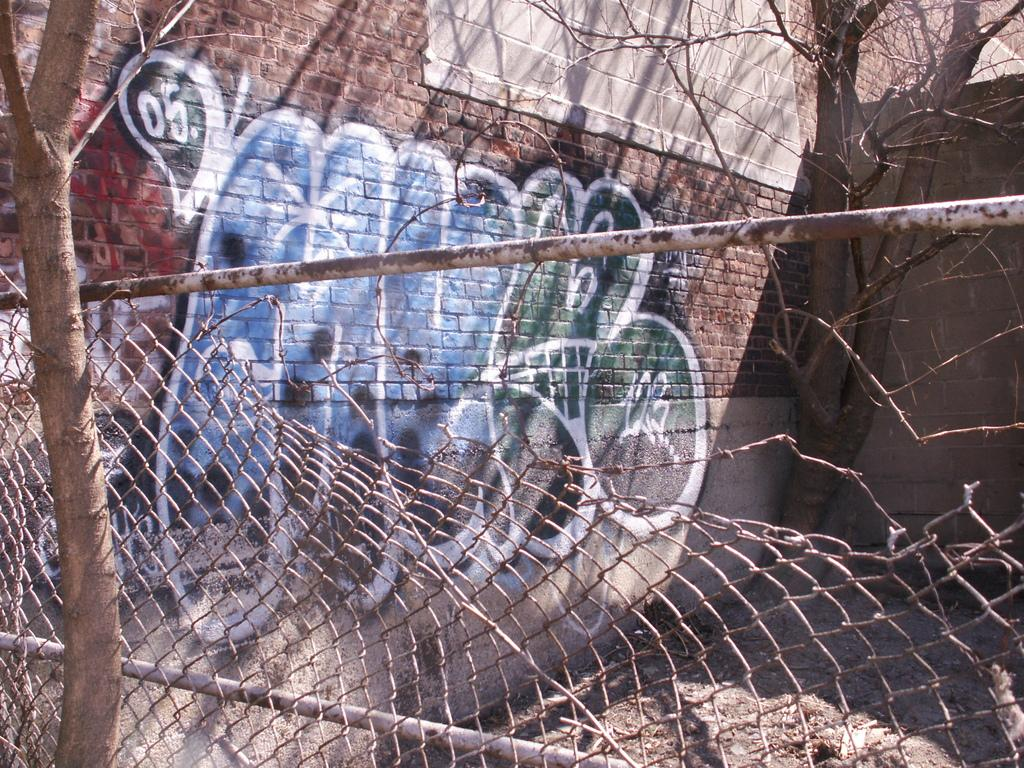What can be seen in the image that might be used for support or safety? There is a railing in the image that might be used for support or safety. What type of natural elements are present in the image? There are trees in the image. What type of artwork is visible in the image? There is a painting on a brick wall in the image. What type of crime is being committed in the image? There is no crime being committed in the image; it features a railing, trees, and a painting on a brick wall. What type of trail can be seen in the image? There is no trail present in the image. 